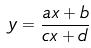Convert formula to latex. <formula><loc_0><loc_0><loc_500><loc_500>y = \frac { a x + b } { c x + d }</formula> 